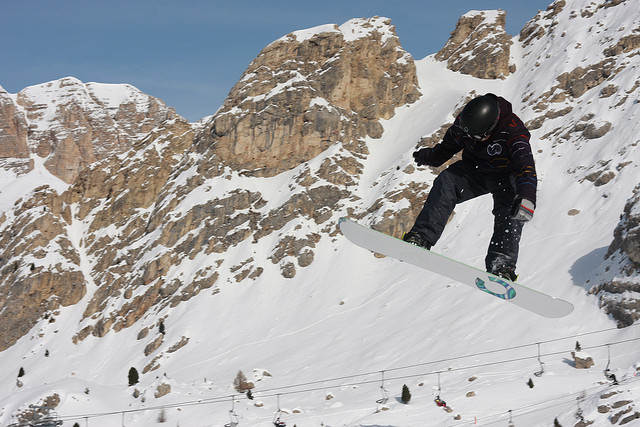What is the position of the snowboarder relative to the mountain? The snowboarder is captured in mid-air, suggesting they have either just executed a jump or are performing a trick. They are positioned closer to the foreground of the image, while the majestic mountainous terrain serves as a dramatic backdrop. 